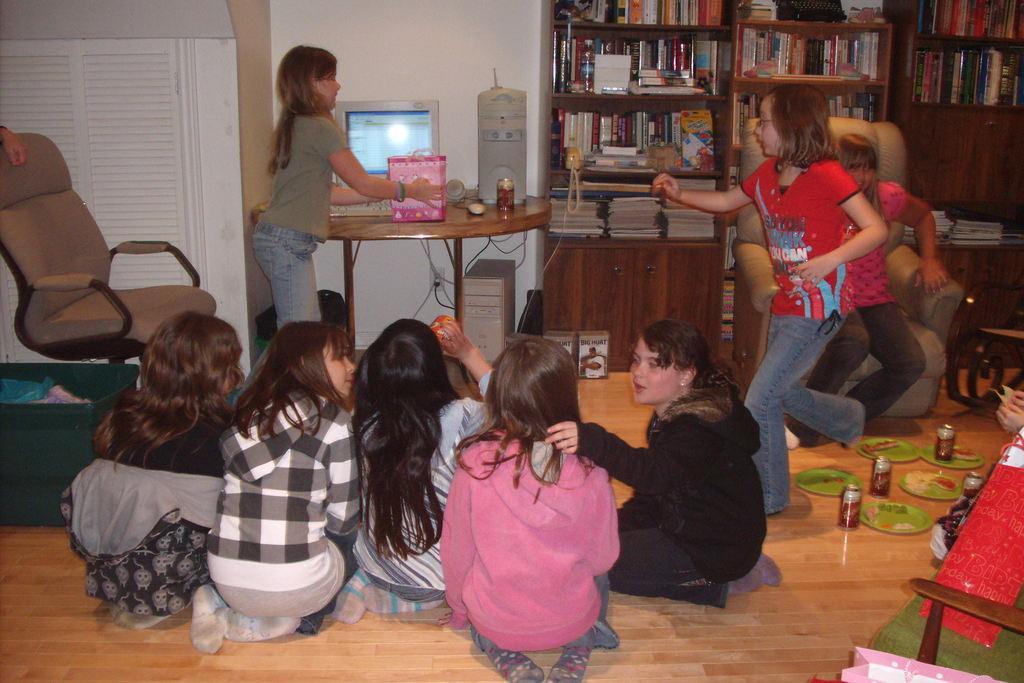In one or two sentences, can you explain what this image depicts? In this image few kids are on the floor having few coke cans and plates. Right side there are racks having few books in it. Beside there is a table having a monitor, keyboard, CPU and few objects. Before the table there was a girl standing and she is holding a bag in her hand. Right side a person is sitting on the chair. A girl is running on the floor. Left side there is a chair on the floor having few objects. Background there is a wall. Right bottom there is a chair having few objects on it. Right side a person's hands are visible. 